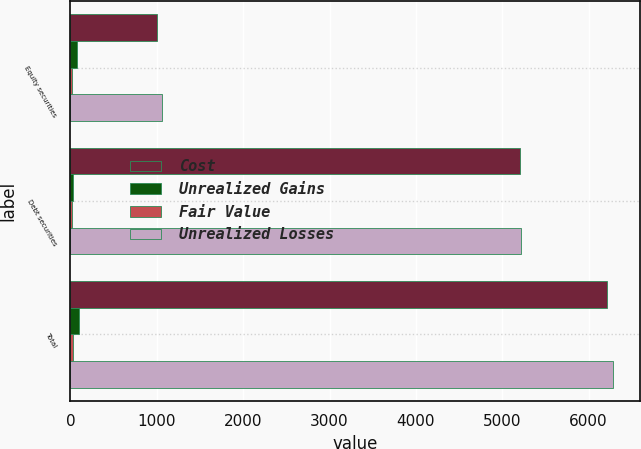<chart> <loc_0><loc_0><loc_500><loc_500><stacked_bar_chart><ecel><fcel>Equity securities<fcel>Debt securities<fcel>Total<nl><fcel>Cost<fcel>1003<fcel>5208<fcel>6211<nl><fcel>Unrealized Gains<fcel>77<fcel>27<fcel>104<nl><fcel>Fair Value<fcel>19<fcel>15<fcel>34<nl><fcel>Unrealized Losses<fcel>1061<fcel>5220<fcel>6281<nl></chart> 